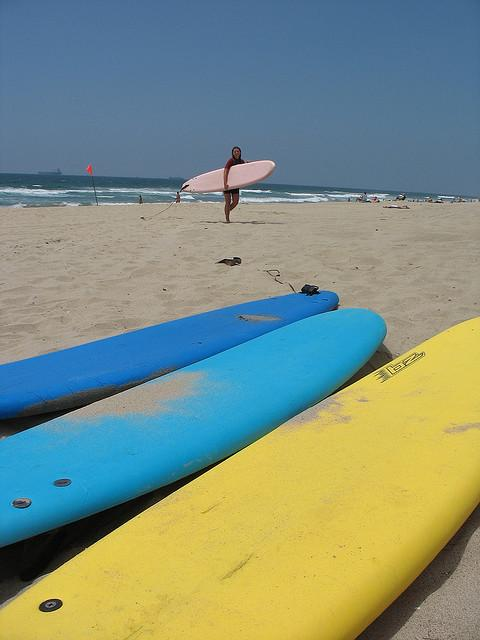Which music group would be able to use all of these boards without sharing? Please explain your reasoning. cream. The rock band cream had three members and there are three boards. 